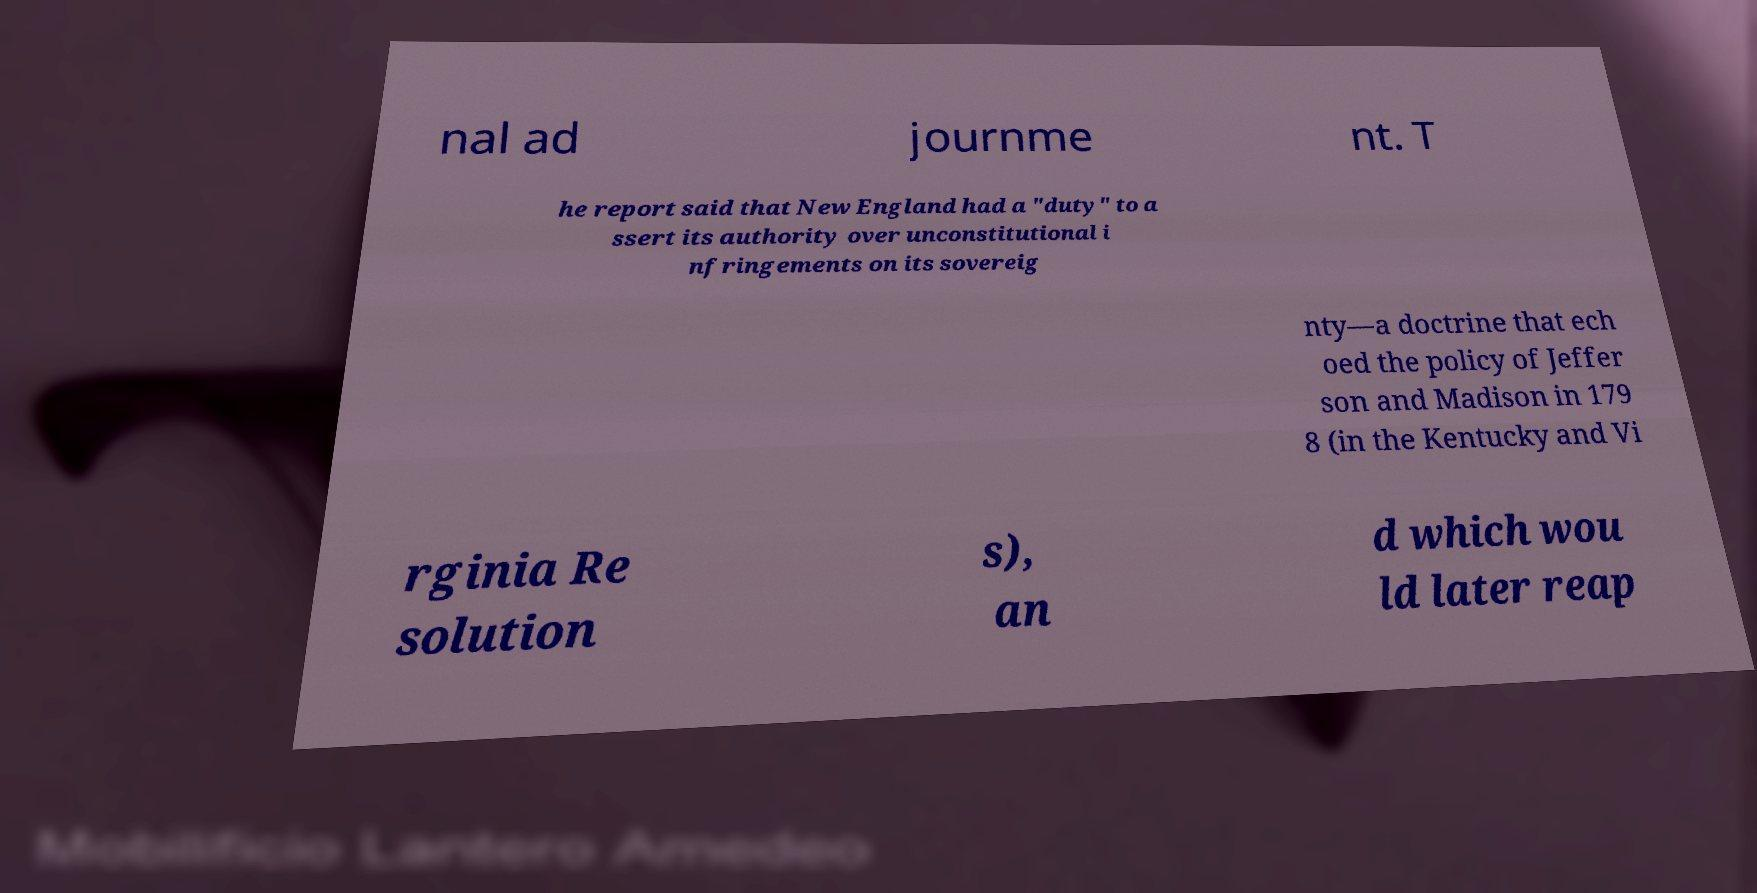What messages or text are displayed in this image? I need them in a readable, typed format. nal ad journme nt. T he report said that New England had a "duty" to a ssert its authority over unconstitutional i nfringements on its sovereig nty—a doctrine that ech oed the policy of Jeffer son and Madison in 179 8 (in the Kentucky and Vi rginia Re solution s), an d which wou ld later reap 